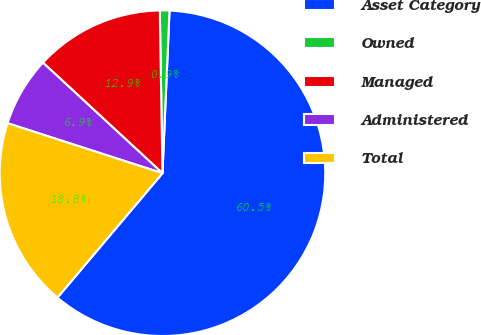Convert chart. <chart><loc_0><loc_0><loc_500><loc_500><pie_chart><fcel>Asset Category<fcel>Owned<fcel>Managed<fcel>Administered<fcel>Total<nl><fcel>60.47%<fcel>0.95%<fcel>12.86%<fcel>6.91%<fcel>18.81%<nl></chart> 